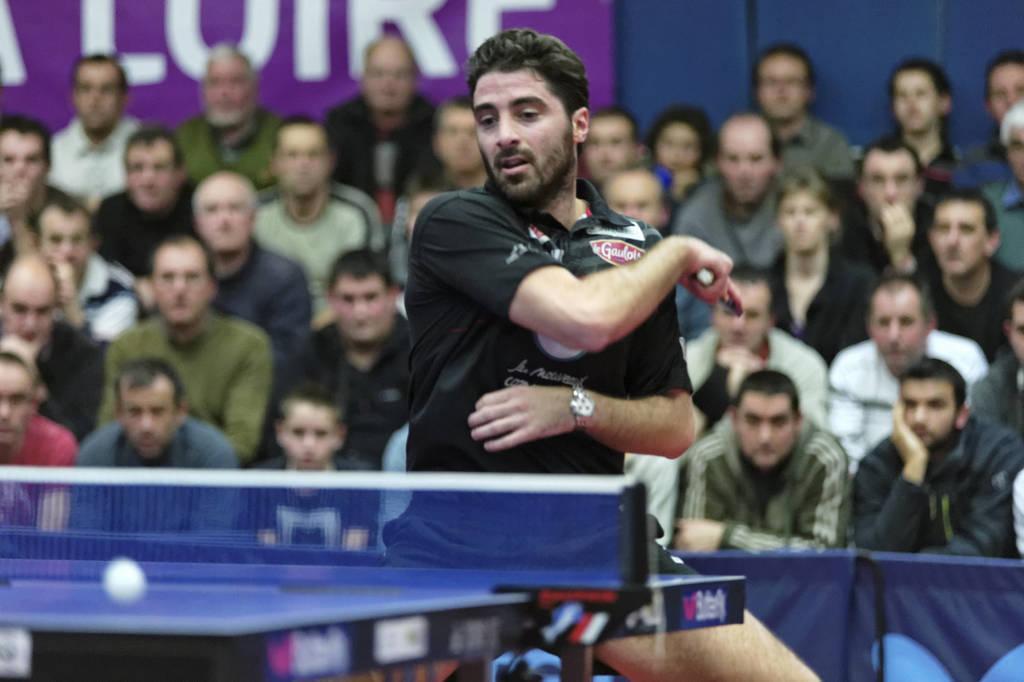Could you give a brief overview of what you see in this image? In this image we can see a few people sitting and also we can see a person standing and playing the table tennis, we can see a table and a ball, in the background we can see a board with some text on it. 